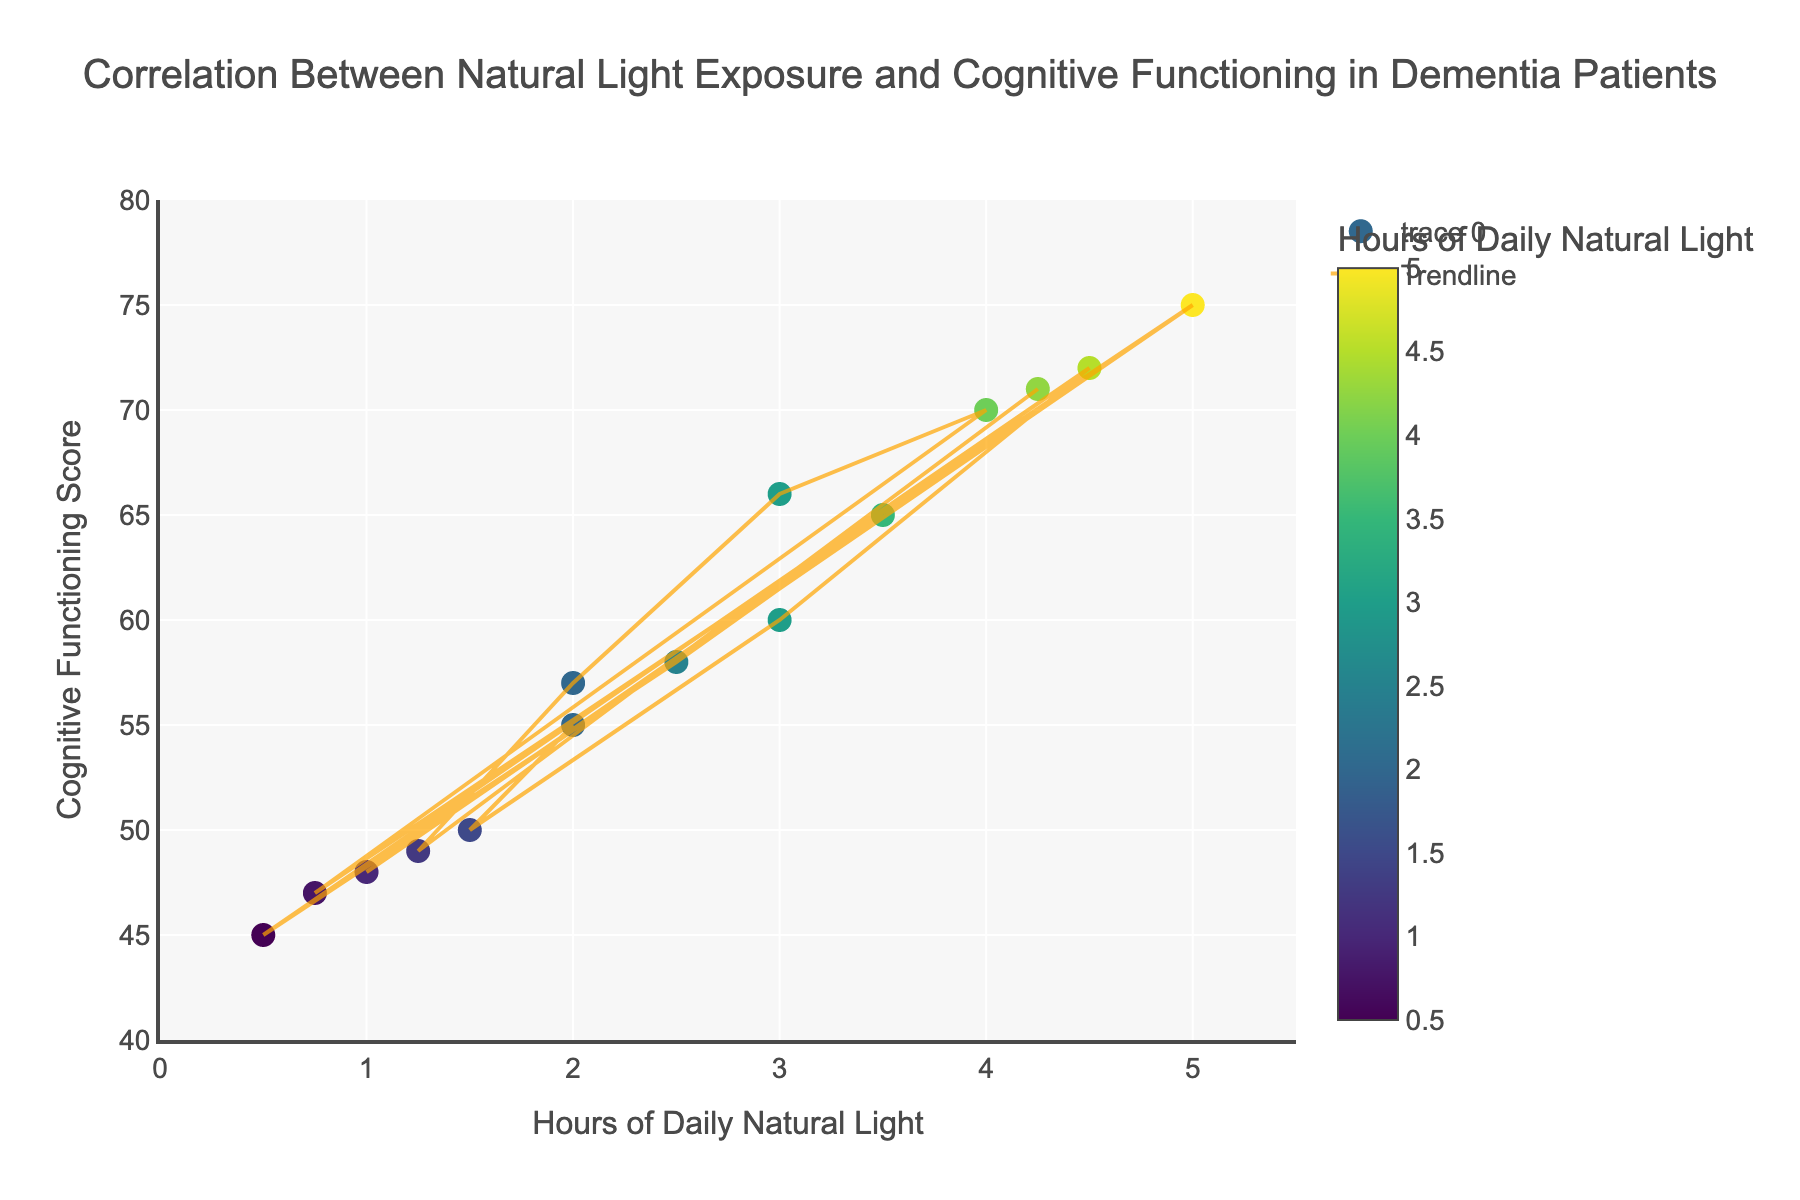What is the title of the plot? The title is displayed at the top center of the plot and reads, "Correlation Between Natural Light Exposure and Cognitive Functioning in Dementia Patients".
Answer: Correlation Between Natural Light Exposure and Cognitive Functioning in Dementia Patients What are the labels of the x-axis and y-axis? The x-axis label is at the bottom of the plot, and it reads "Hours of Daily Natural Light". The y-axis label is along the left side of the plot and it reads "Cognitive Functioning Score".
Answer: Hours of Daily Natural Light; Cognitive Functioning Score How many data points are shown in the scatter plot? Each point on the scatter plot represents a patient. There are 15 unique data points shown in the scatter plot.
Answer: 15 What is the range of hours of daily natural light exposure among the patients? The x-axis indicates the range of hours, starting at 0 and ending at 5.5 hours of daily natural light exposure.
Answer: 0 to 5.5 Which patient has the highest cognitive functioning score, and what is their hours of daily natural light exposure? By hovering over the data points, the patient with the highest cognitive functioning score can be identified. Patient P109 has the highest score of 75 and 5 hours of daily natural light exposure.
Answer: P109; 5 hours What is the trendline color used in the scatter plot? The trendline is shown in the scatter plot as a line with a distinct color, which appears to be orange.
Answer: Orange Compare the cognitive functioning scores of patients P102 and P112. Who has a higher score and by how much? Hovering over the data points shows that P102 has a score of 50 and P112 has a score of 66. The difference between their scores is 66 - 50 = 16.
Answer: P112; 16 points What color scale is used to represent the hours of daily natural light in the scatter plot? The color of the markers changes according to the hours of daily natural light exposure, and the colors range from dark to bright in the "Viridis" color scale.
Answer: Viridis What is the cognitive functioning score for a patient exposed to 1 hour of daily natural light? By hovering over the data points for 1 hour of daily natural light on the x-axis, the corresponding cognitive functioning score is identified. Patient P108, exposed to 1 hour of natural light, has a score of 48.
Answer: 48 What is the average cognitive functioning score for patients exposed to more than 3 hours of natural light daily? Identify the patients exposed to more than 3 hours of natural light (P104, P107, P109, P111, P115). Then, calculate the average score: (72 + 65 + 75 + 70 + 71) / 5 = 70.6.
Answer: 70.6 